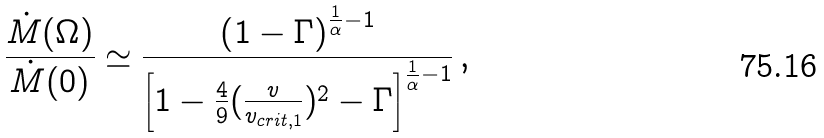<formula> <loc_0><loc_0><loc_500><loc_500>\frac { \dot { M } ( \Omega ) } { \dot { M } ( 0 ) } \simeq \frac { \left ( 1 - \Gamma \right ) ^ { \frac { 1 } { \alpha } - 1 } } { \left [ 1 - \frac { 4 } { 9 } ( \frac { v } { v _ { c r i t , 1 } } ) ^ { 2 } - \Gamma \right ] ^ { \frac { 1 } { \alpha } - 1 } } \, ,</formula> 